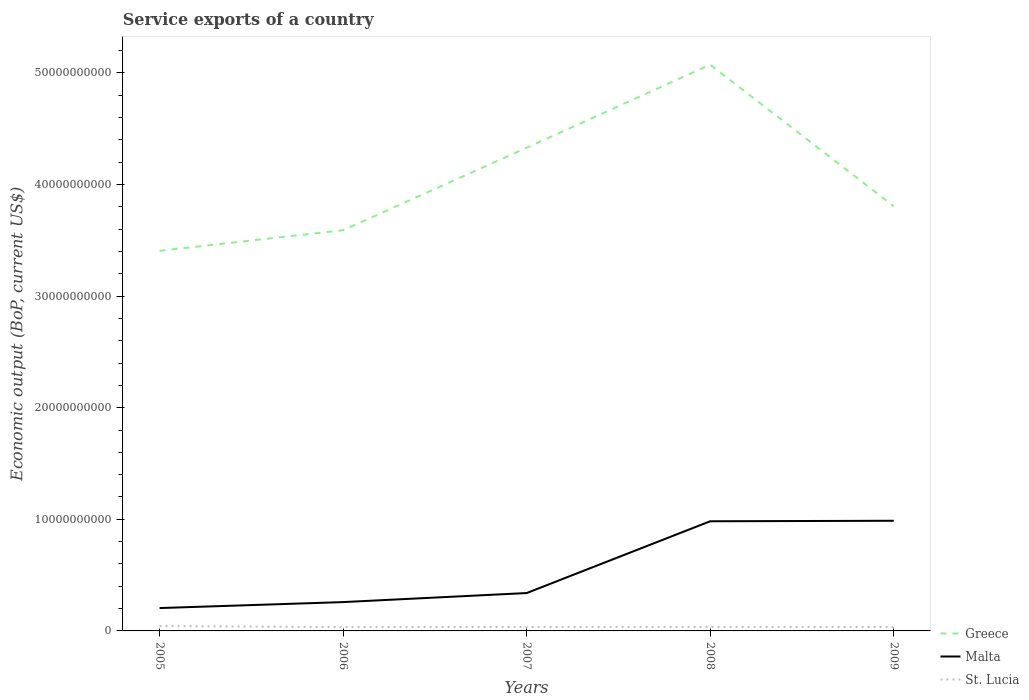How many different coloured lines are there?
Offer a terse response. 3. Does the line corresponding to St. Lucia intersect with the line corresponding to Greece?
Offer a terse response. No. Across all years, what is the maximum service exports in St. Lucia?
Make the answer very short. 3.44e+08. In which year was the service exports in Greece maximum?
Your answer should be compact. 2005. What is the total service exports in Malta in the graph?
Provide a succinct answer. -6.43e+09. What is the difference between the highest and the second highest service exports in Greece?
Your answer should be very brief. 1.67e+1. Is the service exports in Greece strictly greater than the service exports in St. Lucia over the years?
Give a very brief answer. No. How many lines are there?
Make the answer very short. 3. How many years are there in the graph?
Ensure brevity in your answer.  5. What is the difference between two consecutive major ticks on the Y-axis?
Your response must be concise. 1.00e+1. Are the values on the major ticks of Y-axis written in scientific E-notation?
Provide a short and direct response. No. Does the graph contain any zero values?
Your response must be concise. No. Does the graph contain grids?
Your answer should be very brief. No. How many legend labels are there?
Keep it short and to the point. 3. How are the legend labels stacked?
Give a very brief answer. Vertical. What is the title of the graph?
Offer a terse response. Service exports of a country. Does "Mauritius" appear as one of the legend labels in the graph?
Provide a short and direct response. No. What is the label or title of the X-axis?
Provide a short and direct response. Years. What is the label or title of the Y-axis?
Your answer should be compact. Economic output (BoP, current US$). What is the Economic output (BoP, current US$) of Greece in 2005?
Your answer should be compact. 3.41e+1. What is the Economic output (BoP, current US$) in Malta in 2005?
Your answer should be very brief. 2.05e+09. What is the Economic output (BoP, current US$) in St. Lucia in 2005?
Ensure brevity in your answer.  4.36e+08. What is the Economic output (BoP, current US$) of Greece in 2006?
Provide a succinct answer. 3.59e+1. What is the Economic output (BoP, current US$) of Malta in 2006?
Your response must be concise. 2.58e+09. What is the Economic output (BoP, current US$) in St. Lucia in 2006?
Your answer should be very brief. 3.44e+08. What is the Economic output (BoP, current US$) in Greece in 2007?
Provide a succinct answer. 4.33e+1. What is the Economic output (BoP, current US$) of Malta in 2007?
Keep it short and to the point. 3.39e+09. What is the Economic output (BoP, current US$) in St. Lucia in 2007?
Offer a very short reply. 3.56e+08. What is the Economic output (BoP, current US$) in Greece in 2008?
Offer a very short reply. 5.07e+1. What is the Economic output (BoP, current US$) in Malta in 2008?
Keep it short and to the point. 9.82e+09. What is the Economic output (BoP, current US$) in St. Lucia in 2008?
Offer a very short reply. 3.64e+08. What is the Economic output (BoP, current US$) in Greece in 2009?
Provide a succinct answer. 3.80e+1. What is the Economic output (BoP, current US$) in Malta in 2009?
Make the answer very short. 9.87e+09. What is the Economic output (BoP, current US$) in St. Lucia in 2009?
Give a very brief answer. 3.53e+08. Across all years, what is the maximum Economic output (BoP, current US$) of Greece?
Offer a terse response. 5.07e+1. Across all years, what is the maximum Economic output (BoP, current US$) of Malta?
Offer a very short reply. 9.87e+09. Across all years, what is the maximum Economic output (BoP, current US$) of St. Lucia?
Keep it short and to the point. 4.36e+08. Across all years, what is the minimum Economic output (BoP, current US$) of Greece?
Provide a short and direct response. 3.41e+1. Across all years, what is the minimum Economic output (BoP, current US$) of Malta?
Your response must be concise. 2.05e+09. Across all years, what is the minimum Economic output (BoP, current US$) in St. Lucia?
Your answer should be compact. 3.44e+08. What is the total Economic output (BoP, current US$) in Greece in the graph?
Keep it short and to the point. 2.02e+11. What is the total Economic output (BoP, current US$) of Malta in the graph?
Your response must be concise. 2.77e+1. What is the total Economic output (BoP, current US$) in St. Lucia in the graph?
Make the answer very short. 1.85e+09. What is the difference between the Economic output (BoP, current US$) of Greece in 2005 and that in 2006?
Provide a short and direct response. -1.85e+09. What is the difference between the Economic output (BoP, current US$) of Malta in 2005 and that in 2006?
Make the answer very short. -5.35e+08. What is the difference between the Economic output (BoP, current US$) of St. Lucia in 2005 and that in 2006?
Give a very brief answer. 9.26e+07. What is the difference between the Economic output (BoP, current US$) in Greece in 2005 and that in 2007?
Ensure brevity in your answer.  -9.24e+09. What is the difference between the Economic output (BoP, current US$) in Malta in 2005 and that in 2007?
Your answer should be compact. -1.35e+09. What is the difference between the Economic output (BoP, current US$) of St. Lucia in 2005 and that in 2007?
Give a very brief answer. 8.02e+07. What is the difference between the Economic output (BoP, current US$) in Greece in 2005 and that in 2008?
Ensure brevity in your answer.  -1.67e+1. What is the difference between the Economic output (BoP, current US$) of Malta in 2005 and that in 2008?
Offer a very short reply. -7.78e+09. What is the difference between the Economic output (BoP, current US$) in St. Lucia in 2005 and that in 2008?
Offer a terse response. 7.26e+07. What is the difference between the Economic output (BoP, current US$) of Greece in 2005 and that in 2009?
Provide a short and direct response. -3.99e+09. What is the difference between the Economic output (BoP, current US$) of Malta in 2005 and that in 2009?
Offer a terse response. -7.82e+09. What is the difference between the Economic output (BoP, current US$) of St. Lucia in 2005 and that in 2009?
Your answer should be very brief. 8.35e+07. What is the difference between the Economic output (BoP, current US$) of Greece in 2006 and that in 2007?
Ensure brevity in your answer.  -7.39e+09. What is the difference between the Economic output (BoP, current US$) in Malta in 2006 and that in 2007?
Give a very brief answer. -8.10e+08. What is the difference between the Economic output (BoP, current US$) in St. Lucia in 2006 and that in 2007?
Give a very brief answer. -1.23e+07. What is the difference between the Economic output (BoP, current US$) of Greece in 2006 and that in 2008?
Give a very brief answer. -1.48e+1. What is the difference between the Economic output (BoP, current US$) of Malta in 2006 and that in 2008?
Give a very brief answer. -7.24e+09. What is the difference between the Economic output (BoP, current US$) in St. Lucia in 2006 and that in 2008?
Your answer should be very brief. -2.00e+07. What is the difference between the Economic output (BoP, current US$) of Greece in 2006 and that in 2009?
Your response must be concise. -2.15e+09. What is the difference between the Economic output (BoP, current US$) in Malta in 2006 and that in 2009?
Offer a terse response. -7.29e+09. What is the difference between the Economic output (BoP, current US$) in St. Lucia in 2006 and that in 2009?
Keep it short and to the point. -9.07e+06. What is the difference between the Economic output (BoP, current US$) of Greece in 2007 and that in 2008?
Offer a very short reply. -7.44e+09. What is the difference between the Economic output (BoP, current US$) in Malta in 2007 and that in 2008?
Give a very brief answer. -6.43e+09. What is the difference between the Economic output (BoP, current US$) in St. Lucia in 2007 and that in 2008?
Offer a terse response. -7.68e+06. What is the difference between the Economic output (BoP, current US$) in Greece in 2007 and that in 2009?
Offer a terse response. 5.24e+09. What is the difference between the Economic output (BoP, current US$) in Malta in 2007 and that in 2009?
Provide a succinct answer. -6.48e+09. What is the difference between the Economic output (BoP, current US$) of St. Lucia in 2007 and that in 2009?
Make the answer very short. 3.28e+06. What is the difference between the Economic output (BoP, current US$) in Greece in 2008 and that in 2009?
Your response must be concise. 1.27e+1. What is the difference between the Economic output (BoP, current US$) in Malta in 2008 and that in 2009?
Make the answer very short. -4.46e+07. What is the difference between the Economic output (BoP, current US$) of St. Lucia in 2008 and that in 2009?
Provide a short and direct response. 1.10e+07. What is the difference between the Economic output (BoP, current US$) in Greece in 2005 and the Economic output (BoP, current US$) in Malta in 2006?
Your response must be concise. 3.15e+1. What is the difference between the Economic output (BoP, current US$) of Greece in 2005 and the Economic output (BoP, current US$) of St. Lucia in 2006?
Offer a terse response. 3.37e+1. What is the difference between the Economic output (BoP, current US$) in Malta in 2005 and the Economic output (BoP, current US$) in St. Lucia in 2006?
Make the answer very short. 1.70e+09. What is the difference between the Economic output (BoP, current US$) of Greece in 2005 and the Economic output (BoP, current US$) of Malta in 2007?
Your answer should be compact. 3.07e+1. What is the difference between the Economic output (BoP, current US$) of Greece in 2005 and the Economic output (BoP, current US$) of St. Lucia in 2007?
Your response must be concise. 3.37e+1. What is the difference between the Economic output (BoP, current US$) of Malta in 2005 and the Economic output (BoP, current US$) of St. Lucia in 2007?
Provide a short and direct response. 1.69e+09. What is the difference between the Economic output (BoP, current US$) of Greece in 2005 and the Economic output (BoP, current US$) of Malta in 2008?
Your response must be concise. 2.42e+1. What is the difference between the Economic output (BoP, current US$) of Greece in 2005 and the Economic output (BoP, current US$) of St. Lucia in 2008?
Give a very brief answer. 3.37e+1. What is the difference between the Economic output (BoP, current US$) in Malta in 2005 and the Economic output (BoP, current US$) in St. Lucia in 2008?
Your answer should be very brief. 1.68e+09. What is the difference between the Economic output (BoP, current US$) in Greece in 2005 and the Economic output (BoP, current US$) in Malta in 2009?
Provide a succinct answer. 2.42e+1. What is the difference between the Economic output (BoP, current US$) of Greece in 2005 and the Economic output (BoP, current US$) of St. Lucia in 2009?
Keep it short and to the point. 3.37e+1. What is the difference between the Economic output (BoP, current US$) in Malta in 2005 and the Economic output (BoP, current US$) in St. Lucia in 2009?
Ensure brevity in your answer.  1.70e+09. What is the difference between the Economic output (BoP, current US$) in Greece in 2006 and the Economic output (BoP, current US$) in Malta in 2007?
Your answer should be compact. 3.25e+1. What is the difference between the Economic output (BoP, current US$) in Greece in 2006 and the Economic output (BoP, current US$) in St. Lucia in 2007?
Offer a very short reply. 3.55e+1. What is the difference between the Economic output (BoP, current US$) of Malta in 2006 and the Economic output (BoP, current US$) of St. Lucia in 2007?
Offer a terse response. 2.23e+09. What is the difference between the Economic output (BoP, current US$) in Greece in 2006 and the Economic output (BoP, current US$) in Malta in 2008?
Keep it short and to the point. 2.61e+1. What is the difference between the Economic output (BoP, current US$) of Greece in 2006 and the Economic output (BoP, current US$) of St. Lucia in 2008?
Provide a short and direct response. 3.55e+1. What is the difference between the Economic output (BoP, current US$) of Malta in 2006 and the Economic output (BoP, current US$) of St. Lucia in 2008?
Provide a succinct answer. 2.22e+09. What is the difference between the Economic output (BoP, current US$) in Greece in 2006 and the Economic output (BoP, current US$) in Malta in 2009?
Offer a very short reply. 2.60e+1. What is the difference between the Economic output (BoP, current US$) in Greece in 2006 and the Economic output (BoP, current US$) in St. Lucia in 2009?
Your answer should be very brief. 3.55e+1. What is the difference between the Economic output (BoP, current US$) of Malta in 2006 and the Economic output (BoP, current US$) of St. Lucia in 2009?
Your answer should be very brief. 2.23e+09. What is the difference between the Economic output (BoP, current US$) in Greece in 2007 and the Economic output (BoP, current US$) in Malta in 2008?
Your answer should be very brief. 3.35e+1. What is the difference between the Economic output (BoP, current US$) of Greece in 2007 and the Economic output (BoP, current US$) of St. Lucia in 2008?
Provide a succinct answer. 4.29e+1. What is the difference between the Economic output (BoP, current US$) in Malta in 2007 and the Economic output (BoP, current US$) in St. Lucia in 2008?
Make the answer very short. 3.03e+09. What is the difference between the Economic output (BoP, current US$) of Greece in 2007 and the Economic output (BoP, current US$) of Malta in 2009?
Give a very brief answer. 3.34e+1. What is the difference between the Economic output (BoP, current US$) in Greece in 2007 and the Economic output (BoP, current US$) in St. Lucia in 2009?
Give a very brief answer. 4.29e+1. What is the difference between the Economic output (BoP, current US$) in Malta in 2007 and the Economic output (BoP, current US$) in St. Lucia in 2009?
Provide a short and direct response. 3.04e+09. What is the difference between the Economic output (BoP, current US$) in Greece in 2008 and the Economic output (BoP, current US$) in Malta in 2009?
Your answer should be very brief. 4.09e+1. What is the difference between the Economic output (BoP, current US$) of Greece in 2008 and the Economic output (BoP, current US$) of St. Lucia in 2009?
Your response must be concise. 5.04e+1. What is the difference between the Economic output (BoP, current US$) of Malta in 2008 and the Economic output (BoP, current US$) of St. Lucia in 2009?
Offer a very short reply. 9.47e+09. What is the average Economic output (BoP, current US$) of Greece per year?
Ensure brevity in your answer.  4.04e+1. What is the average Economic output (BoP, current US$) of Malta per year?
Ensure brevity in your answer.  5.54e+09. What is the average Economic output (BoP, current US$) of St. Lucia per year?
Keep it short and to the point. 3.70e+08. In the year 2005, what is the difference between the Economic output (BoP, current US$) in Greece and Economic output (BoP, current US$) in Malta?
Your response must be concise. 3.20e+1. In the year 2005, what is the difference between the Economic output (BoP, current US$) in Greece and Economic output (BoP, current US$) in St. Lucia?
Provide a succinct answer. 3.36e+1. In the year 2005, what is the difference between the Economic output (BoP, current US$) of Malta and Economic output (BoP, current US$) of St. Lucia?
Your response must be concise. 1.61e+09. In the year 2006, what is the difference between the Economic output (BoP, current US$) of Greece and Economic output (BoP, current US$) of Malta?
Give a very brief answer. 3.33e+1. In the year 2006, what is the difference between the Economic output (BoP, current US$) in Greece and Economic output (BoP, current US$) in St. Lucia?
Ensure brevity in your answer.  3.56e+1. In the year 2006, what is the difference between the Economic output (BoP, current US$) in Malta and Economic output (BoP, current US$) in St. Lucia?
Offer a very short reply. 2.24e+09. In the year 2007, what is the difference between the Economic output (BoP, current US$) in Greece and Economic output (BoP, current US$) in Malta?
Make the answer very short. 3.99e+1. In the year 2007, what is the difference between the Economic output (BoP, current US$) in Greece and Economic output (BoP, current US$) in St. Lucia?
Ensure brevity in your answer.  4.29e+1. In the year 2007, what is the difference between the Economic output (BoP, current US$) of Malta and Economic output (BoP, current US$) of St. Lucia?
Provide a succinct answer. 3.04e+09. In the year 2008, what is the difference between the Economic output (BoP, current US$) in Greece and Economic output (BoP, current US$) in Malta?
Offer a terse response. 4.09e+1. In the year 2008, what is the difference between the Economic output (BoP, current US$) in Greece and Economic output (BoP, current US$) in St. Lucia?
Offer a very short reply. 5.04e+1. In the year 2008, what is the difference between the Economic output (BoP, current US$) in Malta and Economic output (BoP, current US$) in St. Lucia?
Provide a succinct answer. 9.46e+09. In the year 2009, what is the difference between the Economic output (BoP, current US$) in Greece and Economic output (BoP, current US$) in Malta?
Give a very brief answer. 2.82e+1. In the year 2009, what is the difference between the Economic output (BoP, current US$) of Greece and Economic output (BoP, current US$) of St. Lucia?
Provide a short and direct response. 3.77e+1. In the year 2009, what is the difference between the Economic output (BoP, current US$) in Malta and Economic output (BoP, current US$) in St. Lucia?
Keep it short and to the point. 9.52e+09. What is the ratio of the Economic output (BoP, current US$) of Greece in 2005 to that in 2006?
Provide a succinct answer. 0.95. What is the ratio of the Economic output (BoP, current US$) in Malta in 2005 to that in 2006?
Your answer should be compact. 0.79. What is the ratio of the Economic output (BoP, current US$) in St. Lucia in 2005 to that in 2006?
Your response must be concise. 1.27. What is the ratio of the Economic output (BoP, current US$) in Greece in 2005 to that in 2007?
Your answer should be very brief. 0.79. What is the ratio of the Economic output (BoP, current US$) in Malta in 2005 to that in 2007?
Keep it short and to the point. 0.6. What is the ratio of the Economic output (BoP, current US$) in St. Lucia in 2005 to that in 2007?
Your response must be concise. 1.23. What is the ratio of the Economic output (BoP, current US$) in Greece in 2005 to that in 2008?
Your response must be concise. 0.67. What is the ratio of the Economic output (BoP, current US$) in Malta in 2005 to that in 2008?
Offer a very short reply. 0.21. What is the ratio of the Economic output (BoP, current US$) in St. Lucia in 2005 to that in 2008?
Your answer should be compact. 1.2. What is the ratio of the Economic output (BoP, current US$) of Greece in 2005 to that in 2009?
Make the answer very short. 0.9. What is the ratio of the Economic output (BoP, current US$) of Malta in 2005 to that in 2009?
Offer a very short reply. 0.21. What is the ratio of the Economic output (BoP, current US$) in St. Lucia in 2005 to that in 2009?
Provide a succinct answer. 1.24. What is the ratio of the Economic output (BoP, current US$) of Greece in 2006 to that in 2007?
Your answer should be very brief. 0.83. What is the ratio of the Economic output (BoP, current US$) of Malta in 2006 to that in 2007?
Your response must be concise. 0.76. What is the ratio of the Economic output (BoP, current US$) of St. Lucia in 2006 to that in 2007?
Your answer should be compact. 0.97. What is the ratio of the Economic output (BoP, current US$) in Greece in 2006 to that in 2008?
Your response must be concise. 0.71. What is the ratio of the Economic output (BoP, current US$) in Malta in 2006 to that in 2008?
Your answer should be compact. 0.26. What is the ratio of the Economic output (BoP, current US$) of St. Lucia in 2006 to that in 2008?
Provide a short and direct response. 0.94. What is the ratio of the Economic output (BoP, current US$) in Greece in 2006 to that in 2009?
Provide a short and direct response. 0.94. What is the ratio of the Economic output (BoP, current US$) in Malta in 2006 to that in 2009?
Your answer should be compact. 0.26. What is the ratio of the Economic output (BoP, current US$) of St. Lucia in 2006 to that in 2009?
Ensure brevity in your answer.  0.97. What is the ratio of the Economic output (BoP, current US$) in Greece in 2007 to that in 2008?
Your answer should be compact. 0.85. What is the ratio of the Economic output (BoP, current US$) of Malta in 2007 to that in 2008?
Provide a short and direct response. 0.35. What is the ratio of the Economic output (BoP, current US$) of St. Lucia in 2007 to that in 2008?
Your answer should be compact. 0.98. What is the ratio of the Economic output (BoP, current US$) in Greece in 2007 to that in 2009?
Your answer should be compact. 1.14. What is the ratio of the Economic output (BoP, current US$) of Malta in 2007 to that in 2009?
Make the answer very short. 0.34. What is the ratio of the Economic output (BoP, current US$) of St. Lucia in 2007 to that in 2009?
Provide a short and direct response. 1.01. What is the ratio of the Economic output (BoP, current US$) of St. Lucia in 2008 to that in 2009?
Your answer should be very brief. 1.03. What is the difference between the highest and the second highest Economic output (BoP, current US$) in Greece?
Offer a terse response. 7.44e+09. What is the difference between the highest and the second highest Economic output (BoP, current US$) of Malta?
Give a very brief answer. 4.46e+07. What is the difference between the highest and the second highest Economic output (BoP, current US$) in St. Lucia?
Your answer should be very brief. 7.26e+07. What is the difference between the highest and the lowest Economic output (BoP, current US$) in Greece?
Provide a short and direct response. 1.67e+1. What is the difference between the highest and the lowest Economic output (BoP, current US$) in Malta?
Keep it short and to the point. 7.82e+09. What is the difference between the highest and the lowest Economic output (BoP, current US$) of St. Lucia?
Give a very brief answer. 9.26e+07. 